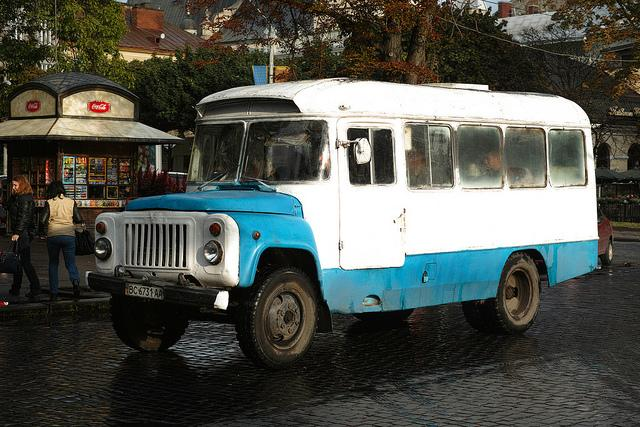What part of the bus needs good traction to ride safely?

Choices:
A) tires
B) motor
C) door
D) windows tires 